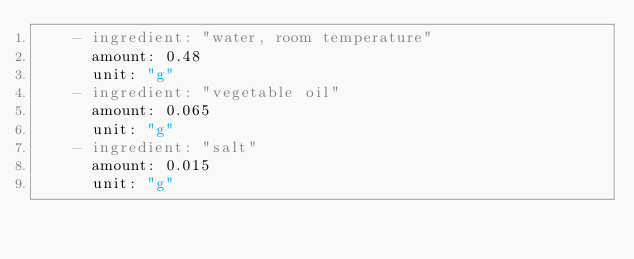<code> <loc_0><loc_0><loc_500><loc_500><_YAML_>    - ingredient: "water, room temperature"
      amount: 0.48
      unit: "g"
    - ingredient: "vegetable oil"
      amount: 0.065
      unit: "g"
    - ingredient: "salt"
      amount: 0.015
      unit: "g"
</code> 